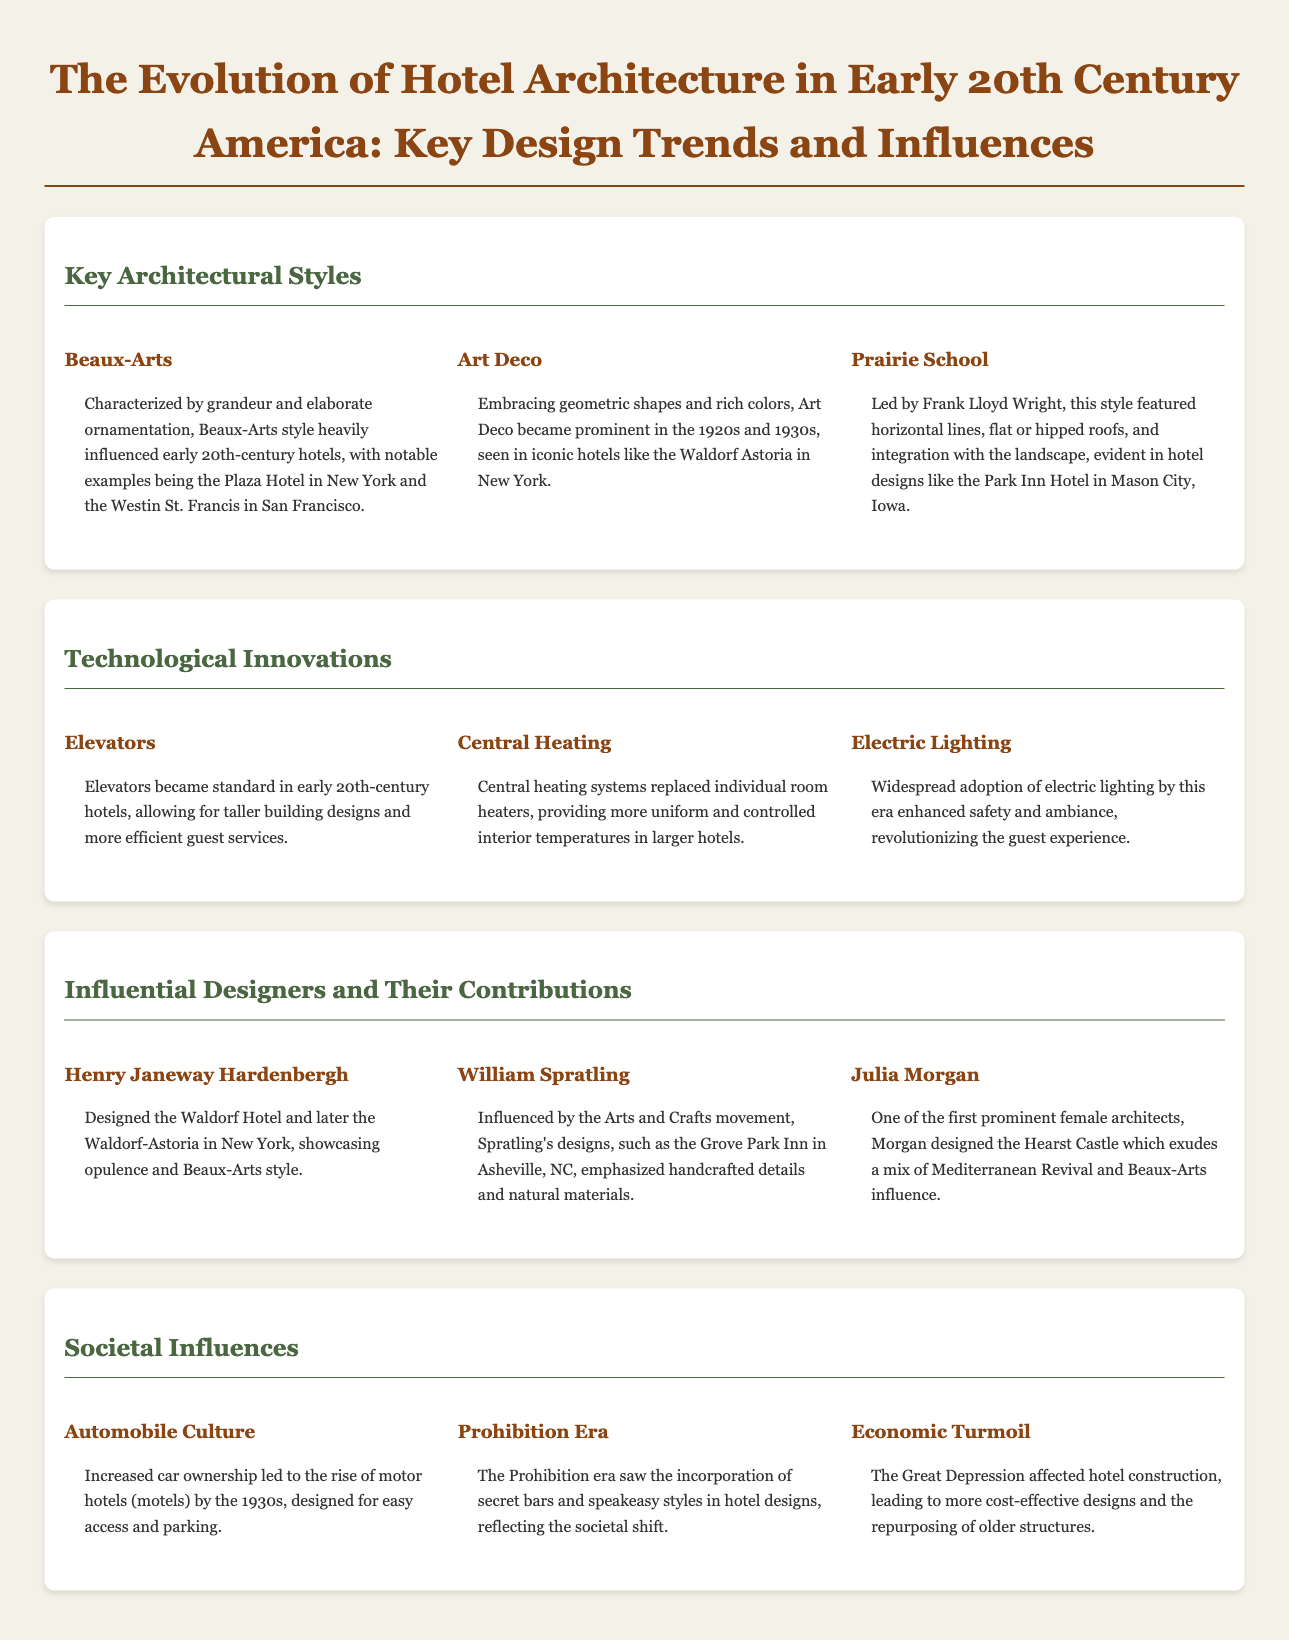What architectural style is characterized by grandeur and elaborate ornamentation? The Beaux-Arts style is noted for its grandeur and elaborate ornamentation, influencing early 20th-century hotels.
Answer: Beaux-Arts Which hotel is an example of Art Deco architecture? The Waldorf Astoria in New York is cited as an iconic hotel showcasing Art Deco style.
Answer: Waldorf Astoria Who designed the Hearst Castle? Julia Morgan designed the Hearst Castle, showcasing Mediterranean Revival and Beaux-Arts influences.
Answer: Julia Morgan What technological innovation allowed for taller hotel designs? The introduction of elevators became standard in hotels, enabling more efficient guest services and taller buildings.
Answer: Elevators What societal change led to the rise of motor hotels? Increased car ownership drove the popularity of motor hotels or motels by the 1930s.
Answer: Automobile Culture Which era influenced hotel designs with secret bars? The Prohibition era saw secret bars and speakeasy styles incorporated into hotel designs, adapting to societal shifts.
Answer: Prohibition Era What was a significant effect of economic turmoil on hotel construction? The Great Depression led to more cost-effective hotel designs and repurposing older structures.
Answer: Economic Turmoil Which influential designer showcased opulence in their work? Henry Janeway Hardenbergh designed the Waldorf Hotel, reflecting opulence and Beaux-Arts style.
Answer: Henry Janeway Hardenbergh 